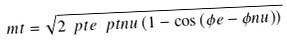Convert formula to latex. <formula><loc_0><loc_0><loc_500><loc_500>\ m t = \sqrt { 2 \ p t e \ p t n u \left ( 1 - \cos \left ( \phi e - \phi n u \right ) \right ) }</formula> 